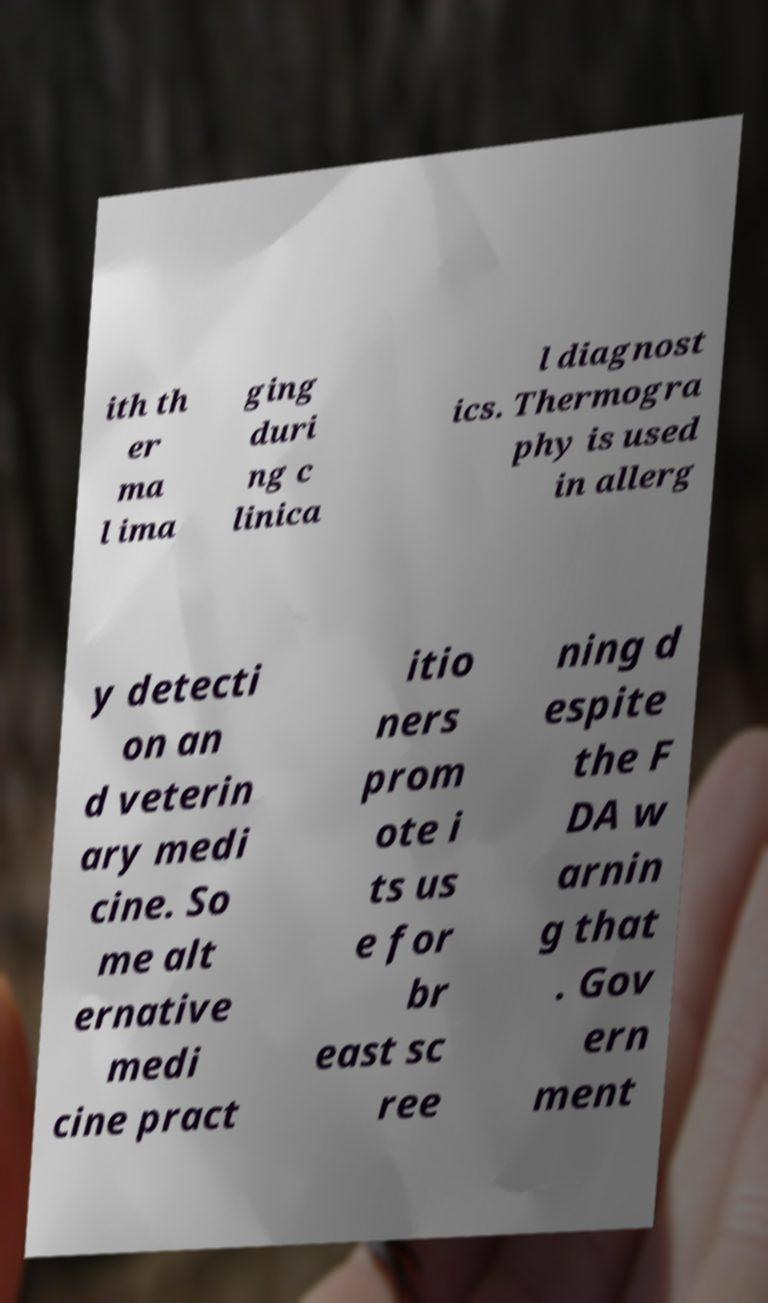Can you accurately transcribe the text from the provided image for me? ith th er ma l ima ging duri ng c linica l diagnost ics. Thermogra phy is used in allerg y detecti on an d veterin ary medi cine. So me alt ernative medi cine pract itio ners prom ote i ts us e for br east sc ree ning d espite the F DA w arnin g that . Gov ern ment 